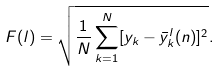<formula> <loc_0><loc_0><loc_500><loc_500>F ( l ) = \sqrt { \frac { 1 } { N } \sum _ { k = 1 } ^ { N } [ y _ { k } - \bar { y } _ { k } ^ { l } ( n ) ] ^ { 2 } } .</formula> 